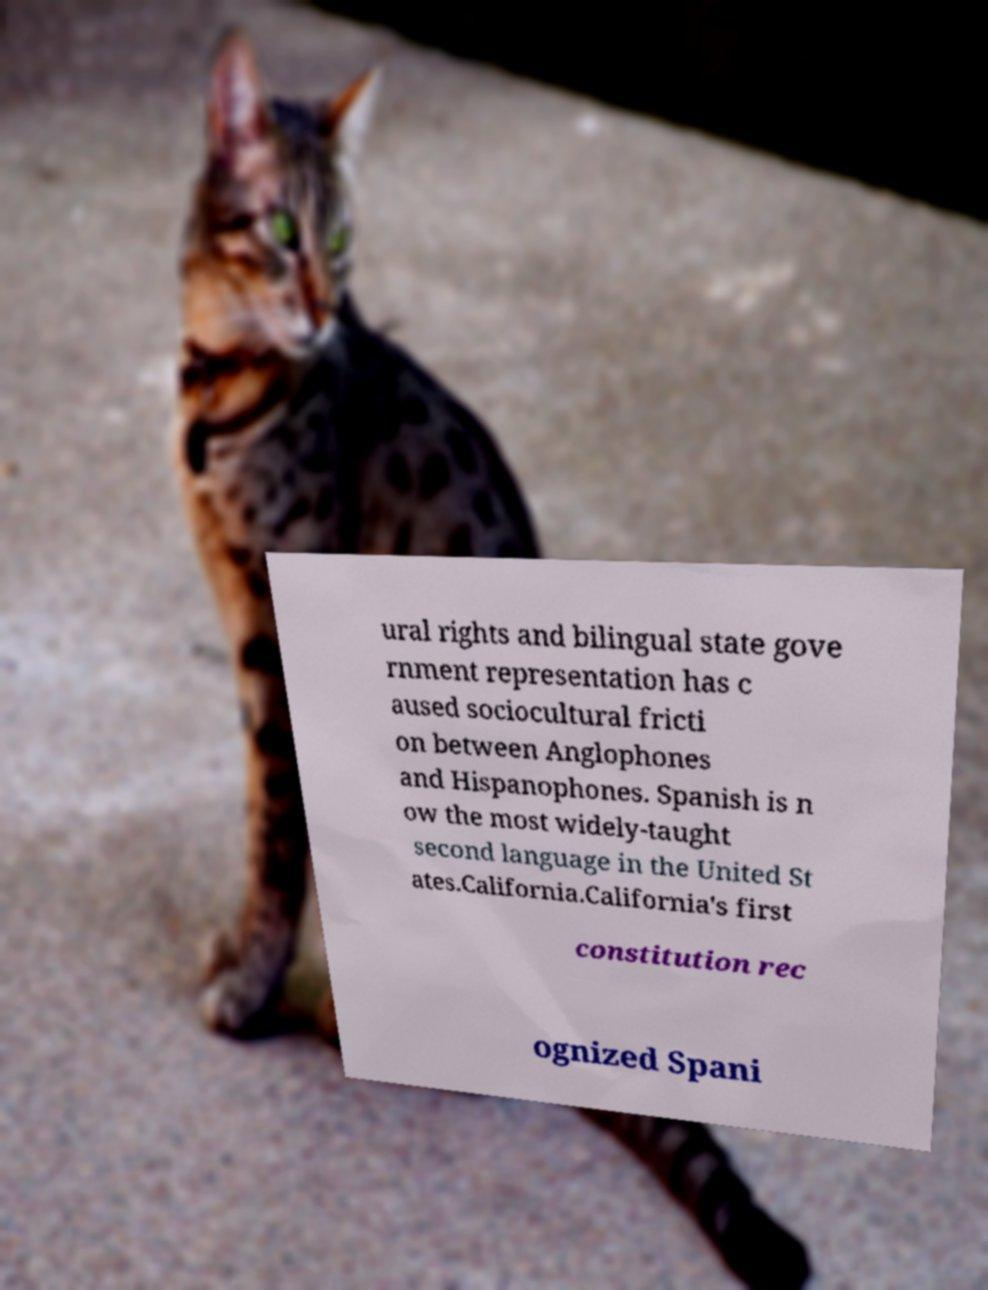Could you extract and type out the text from this image? ural rights and bilingual state gove rnment representation has c aused sociocultural fricti on between Anglophones and Hispanophones. Spanish is n ow the most widely-taught second language in the United St ates.California.California's first constitution rec ognized Spani 